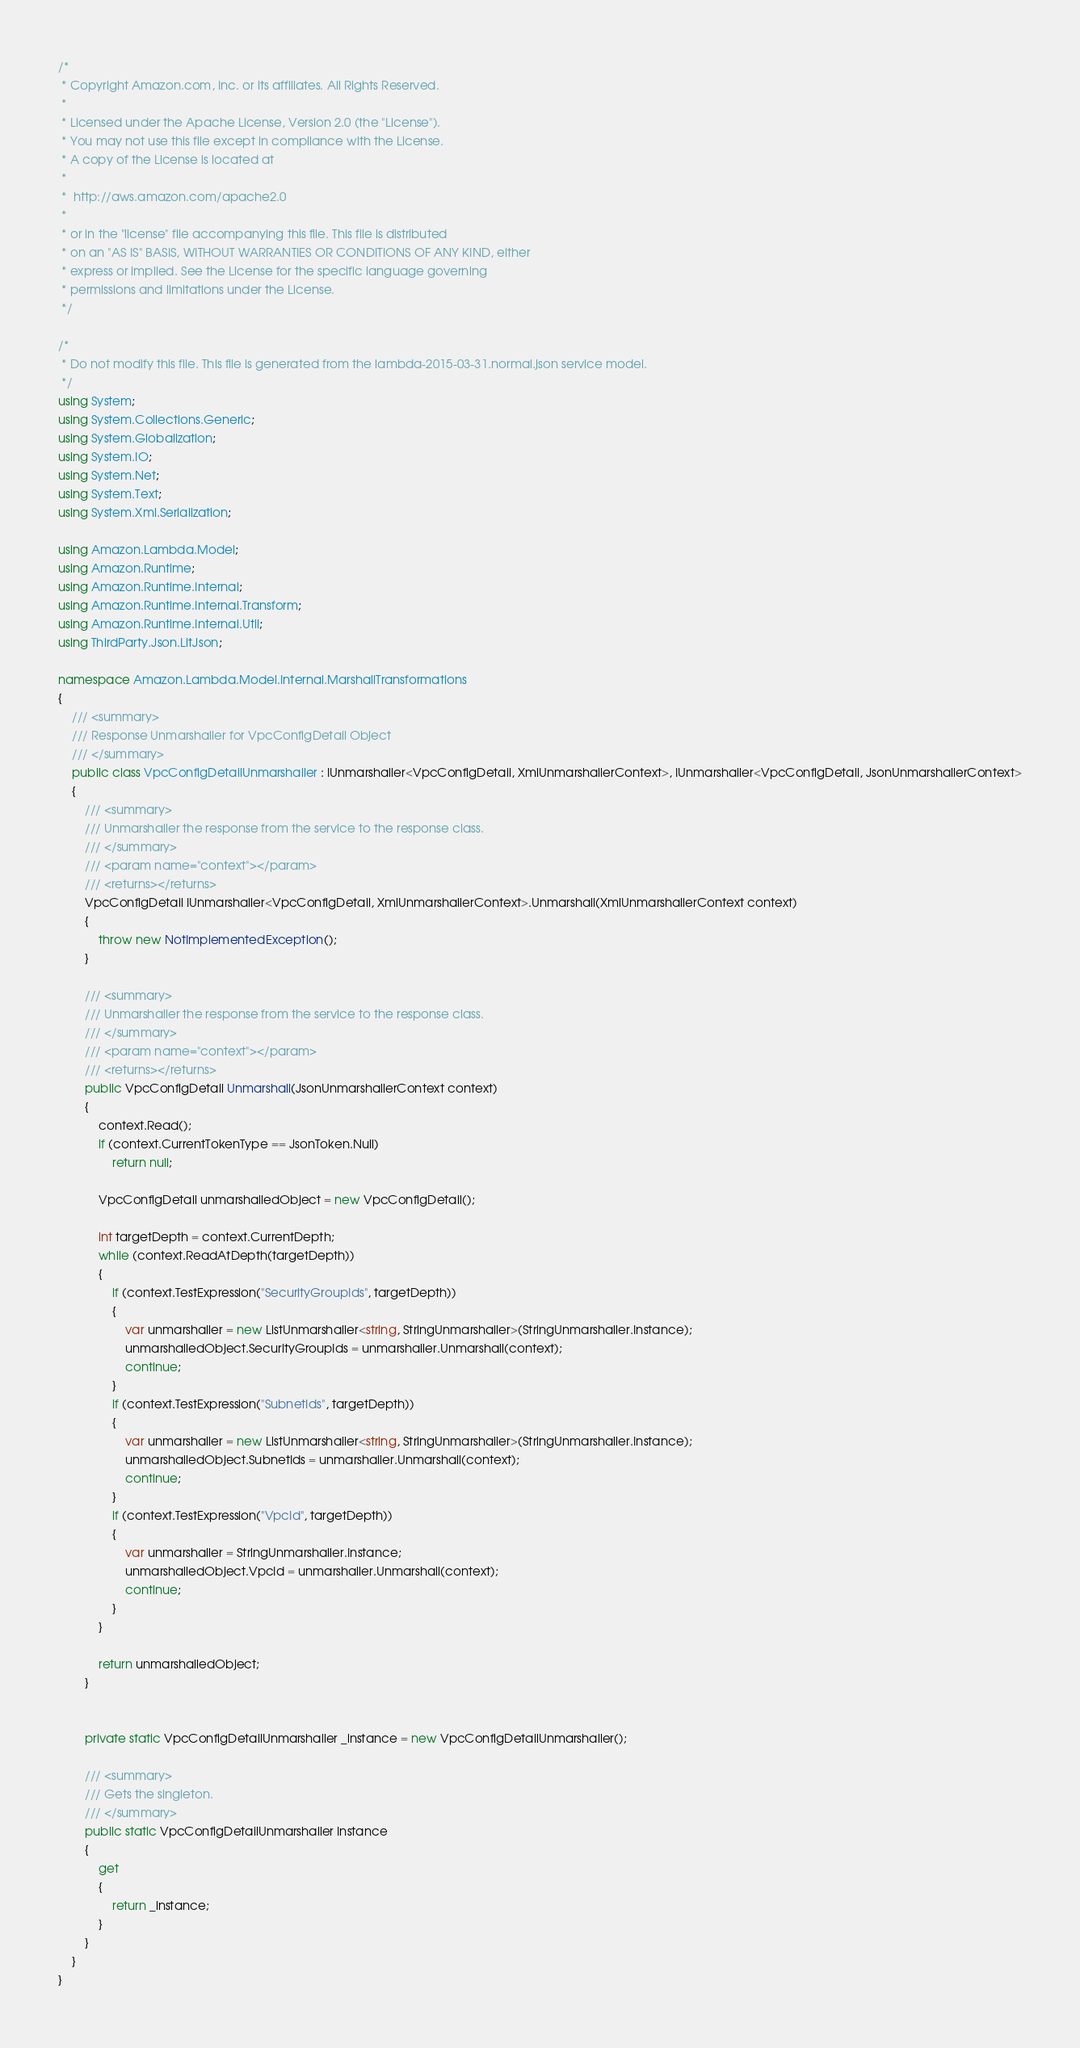<code> <loc_0><loc_0><loc_500><loc_500><_C#_>/*
 * Copyright Amazon.com, Inc. or its affiliates. All Rights Reserved.
 * 
 * Licensed under the Apache License, Version 2.0 (the "License").
 * You may not use this file except in compliance with the License.
 * A copy of the License is located at
 * 
 *  http://aws.amazon.com/apache2.0
 * 
 * or in the "license" file accompanying this file. This file is distributed
 * on an "AS IS" BASIS, WITHOUT WARRANTIES OR CONDITIONS OF ANY KIND, either
 * express or implied. See the License for the specific language governing
 * permissions and limitations under the License.
 */

/*
 * Do not modify this file. This file is generated from the lambda-2015-03-31.normal.json service model.
 */
using System;
using System.Collections.Generic;
using System.Globalization;
using System.IO;
using System.Net;
using System.Text;
using System.Xml.Serialization;

using Amazon.Lambda.Model;
using Amazon.Runtime;
using Amazon.Runtime.Internal;
using Amazon.Runtime.Internal.Transform;
using Amazon.Runtime.Internal.Util;
using ThirdParty.Json.LitJson;

namespace Amazon.Lambda.Model.Internal.MarshallTransformations
{
    /// <summary>
    /// Response Unmarshaller for VpcConfigDetail Object
    /// </summary>  
    public class VpcConfigDetailUnmarshaller : IUnmarshaller<VpcConfigDetail, XmlUnmarshallerContext>, IUnmarshaller<VpcConfigDetail, JsonUnmarshallerContext>
    {
        /// <summary>
        /// Unmarshaller the response from the service to the response class.
        /// </summary>  
        /// <param name="context"></param>
        /// <returns></returns>
        VpcConfigDetail IUnmarshaller<VpcConfigDetail, XmlUnmarshallerContext>.Unmarshall(XmlUnmarshallerContext context)
        {
            throw new NotImplementedException();
        }

        /// <summary>
        /// Unmarshaller the response from the service to the response class.
        /// </summary>  
        /// <param name="context"></param>
        /// <returns></returns>
        public VpcConfigDetail Unmarshall(JsonUnmarshallerContext context)
        {
            context.Read();
            if (context.CurrentTokenType == JsonToken.Null) 
                return null;

            VpcConfigDetail unmarshalledObject = new VpcConfigDetail();
        
            int targetDepth = context.CurrentDepth;
            while (context.ReadAtDepth(targetDepth))
            {
                if (context.TestExpression("SecurityGroupIds", targetDepth))
                {
                    var unmarshaller = new ListUnmarshaller<string, StringUnmarshaller>(StringUnmarshaller.Instance);
                    unmarshalledObject.SecurityGroupIds = unmarshaller.Unmarshall(context);
                    continue;
                }
                if (context.TestExpression("SubnetIds", targetDepth))
                {
                    var unmarshaller = new ListUnmarshaller<string, StringUnmarshaller>(StringUnmarshaller.Instance);
                    unmarshalledObject.SubnetIds = unmarshaller.Unmarshall(context);
                    continue;
                }
                if (context.TestExpression("VpcId", targetDepth))
                {
                    var unmarshaller = StringUnmarshaller.Instance;
                    unmarshalledObject.VpcId = unmarshaller.Unmarshall(context);
                    continue;
                }
            }
          
            return unmarshalledObject;
        }


        private static VpcConfigDetailUnmarshaller _instance = new VpcConfigDetailUnmarshaller();        

        /// <summary>
        /// Gets the singleton.
        /// </summary>  
        public static VpcConfigDetailUnmarshaller Instance
        {
            get
            {
                return _instance;
            }
        }
    }
}</code> 